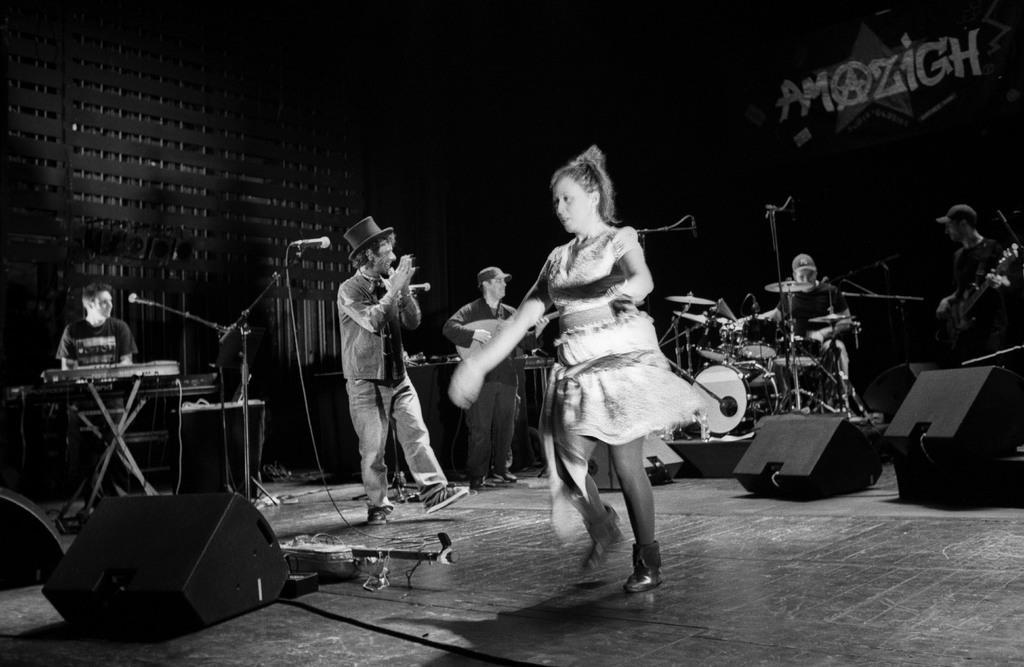Can you describe this image briefly? These three persons are standing and these two persons are sitting, these four person are playing musical instruments,this person dancing. We can see electrical objects and musical instrument on the floor. On the background we can see wall,banner. 